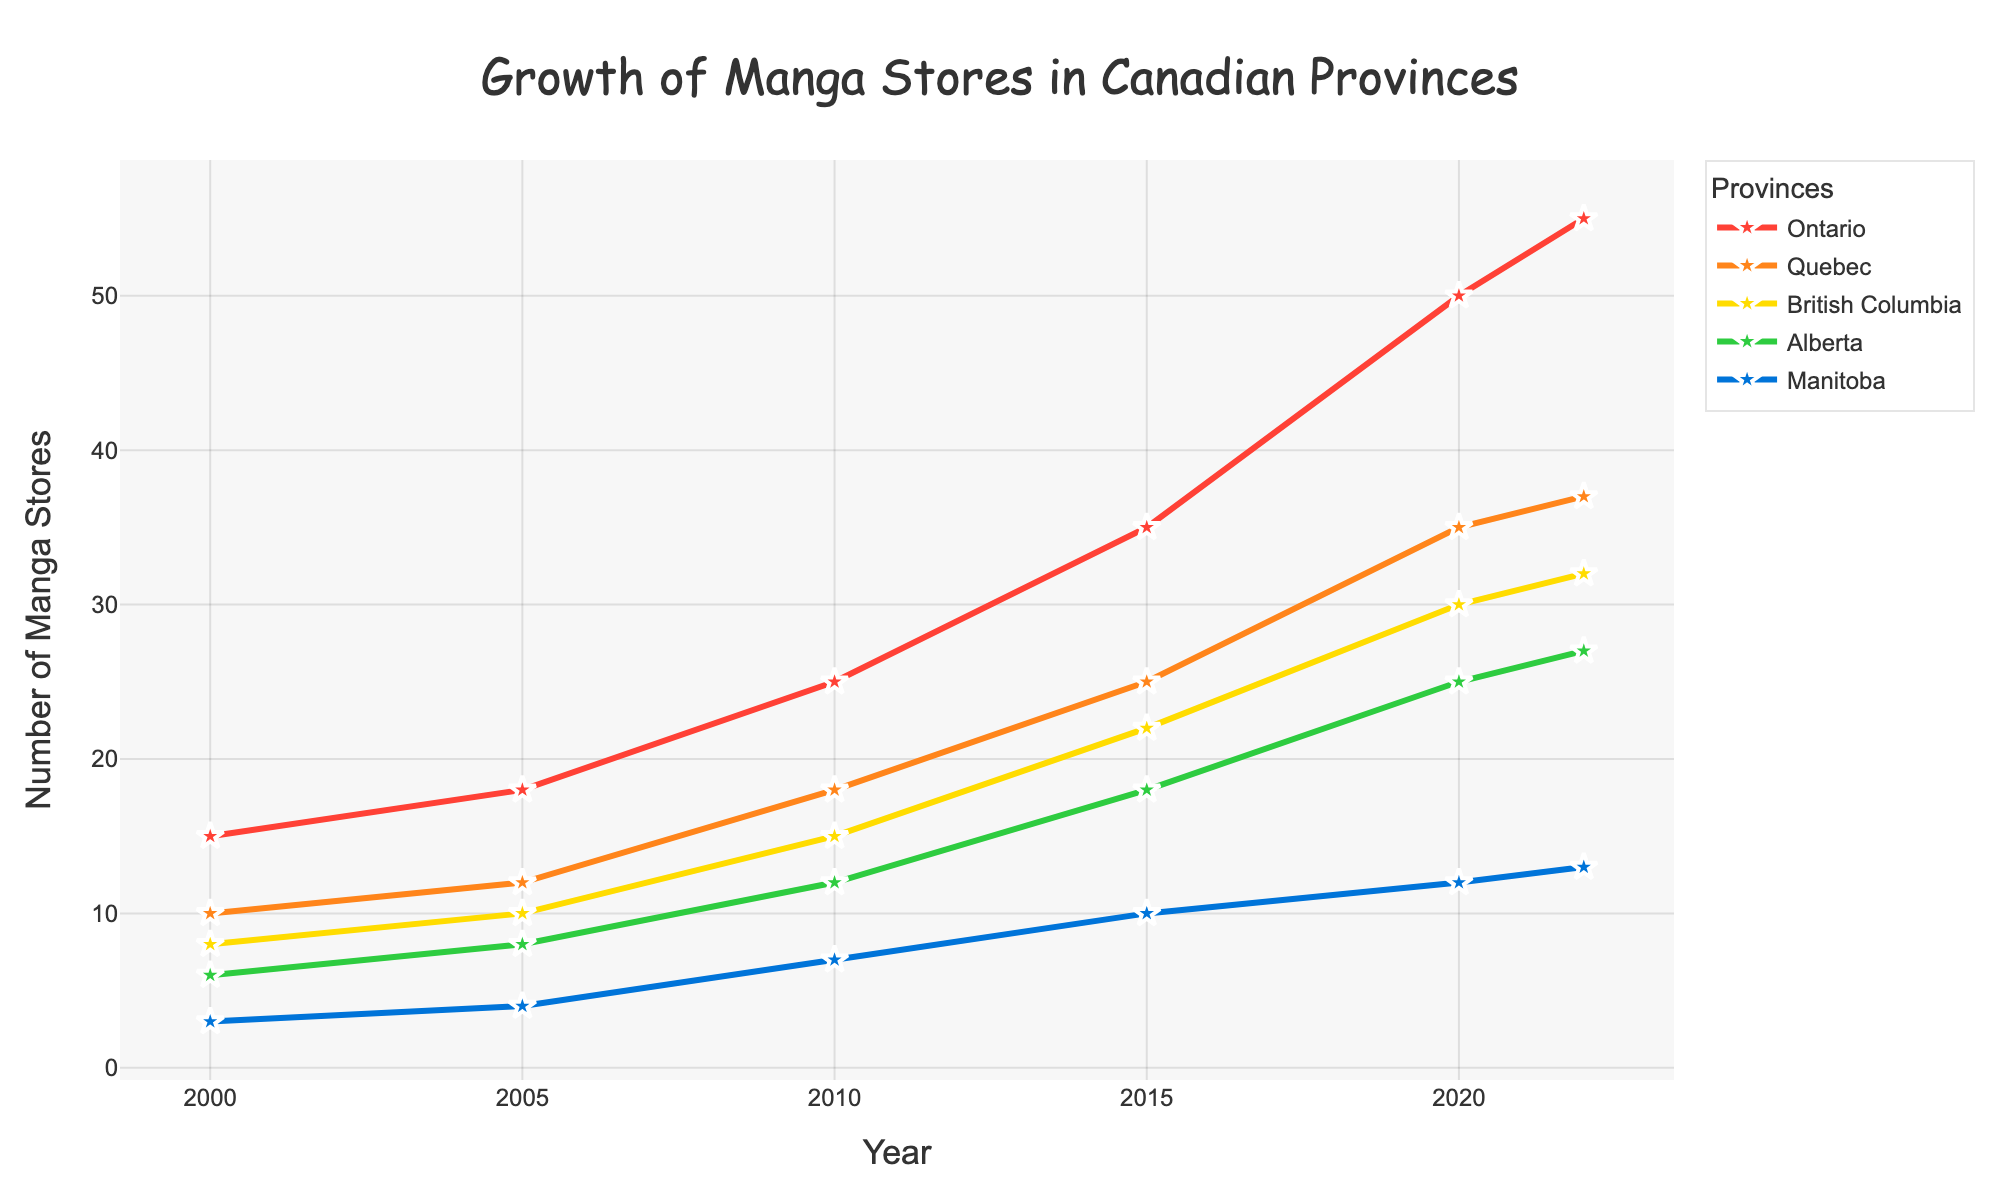What's the title of the figure? The title is located at the top of the figure and reads "Growth of Manga Stores in Canadian Provinces"
Answer: Growth of Manga Stores in Canadian Provinces Which province had the most manga stores in 2000? Look at the 2000 data points and see which line is higher. In 2000, Ontario had the highest number of manga stores.
Answer: Ontario How many manga stores were there in Manitoba in 2022? Find Manitoba on the figure and locate the point for the year 2022 to find its value. There were 13 manga stores in Manitoba in 2022.
Answer: 13 Which province saw the largest increase in manga stores from 2000 to 2022? Compare the number of manga stores in 2000 and 2022 for each province and find the largest difference. Ontario saw the largest increase, going from 15 to 55.
Answer: Ontario Was the number of manga stores in Alberta always less than in Quebec from 2000 to 2022? Compare Alberta's and Quebec's data points across all years. Yes, Alberta always had fewer stores than Quebec in all years displayed.
Answer: Yes By how many did the number of manga stores in British Columbia increase from 2005 to 2010? Look at British Columbia's data points for 2005 and 2010 and calculate the difference: 15 - 10 = 5. The number increased by 5 stores.
Answer: 5 Is the trend of manga store growth in Ontario linear, exponential, or otherwise? Observe the slope of Ontario's line over the years. The trend is more exponential as the increases become steeper over time.
Answer: Exponential How many more manga stores were there in Ontario compared to Manitoba in 2015? Check the 2015 values for Ontario and Manitoba and find the difference, 35 (Ontario) - 10 (Manitoba) = 25. Ontario had 25 more stores.
Answer: 25 Which years does the x-axis cover, and what is the interval tick? The x-axis ranges from 2000 to 2022 with an interval tick of 5 years.
Answer: 2000 to 2022, 5 years What is Alberta’s average number of manga stores over the entire period? Sum Alberta's values (6 + 8 + 12 + 18 + 25 + 27 = 96) and divide by the number of data points (6). Alberta's average is 96 / 6 = 16.
Answer: 16 